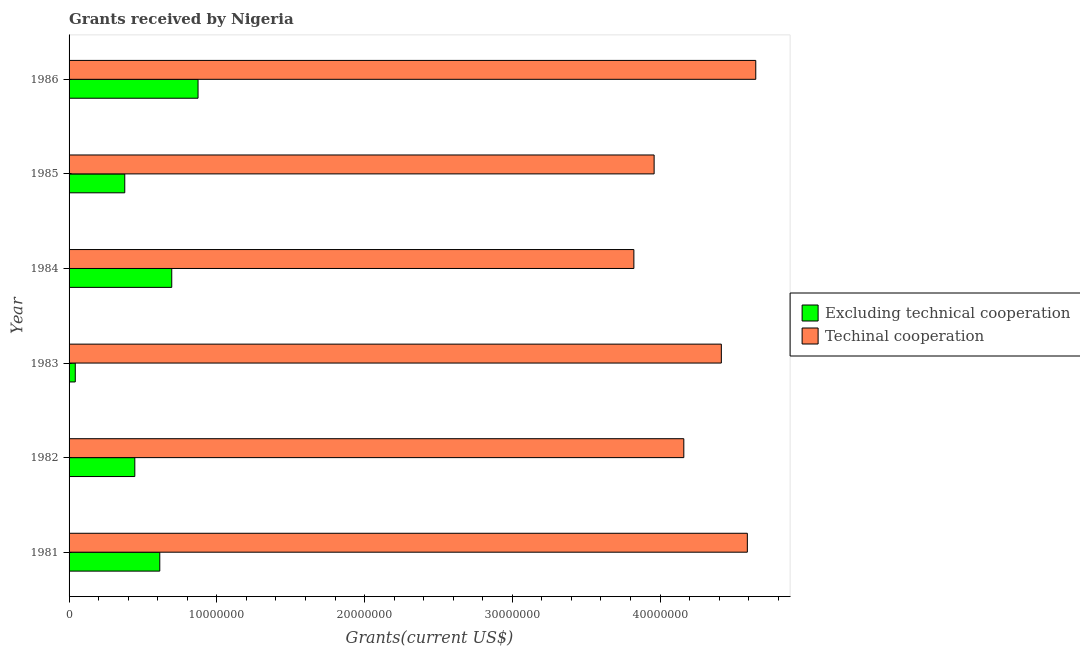How many different coloured bars are there?
Provide a short and direct response. 2. How many bars are there on the 1st tick from the top?
Offer a very short reply. 2. How many bars are there on the 1st tick from the bottom?
Keep it short and to the point. 2. What is the amount of grants received(excluding technical cooperation) in 1986?
Ensure brevity in your answer.  8.73e+06. Across all years, what is the maximum amount of grants received(including technical cooperation)?
Ensure brevity in your answer.  4.65e+07. Across all years, what is the minimum amount of grants received(including technical cooperation)?
Give a very brief answer. 3.82e+07. In which year was the amount of grants received(excluding technical cooperation) minimum?
Give a very brief answer. 1983. What is the total amount of grants received(excluding technical cooperation) in the graph?
Offer a very short reply. 3.05e+07. What is the difference between the amount of grants received(excluding technical cooperation) in 1984 and that in 1986?
Ensure brevity in your answer.  -1.78e+06. What is the difference between the amount of grants received(including technical cooperation) in 1986 and the amount of grants received(excluding technical cooperation) in 1984?
Your answer should be compact. 3.95e+07. What is the average amount of grants received(excluding technical cooperation) per year?
Provide a succinct answer. 5.08e+06. In the year 1981, what is the difference between the amount of grants received(excluding technical cooperation) and amount of grants received(including technical cooperation)?
Offer a very short reply. -3.98e+07. In how many years, is the amount of grants received(excluding technical cooperation) greater than 38000000 US$?
Make the answer very short. 0. What is the ratio of the amount of grants received(including technical cooperation) in 1981 to that in 1986?
Provide a succinct answer. 0.99. Is the amount of grants received(excluding technical cooperation) in 1983 less than that in 1986?
Offer a terse response. Yes. What is the difference between the highest and the second highest amount of grants received(excluding technical cooperation)?
Provide a short and direct response. 1.78e+06. What is the difference between the highest and the lowest amount of grants received(including technical cooperation)?
Offer a very short reply. 8.25e+06. Is the sum of the amount of grants received(excluding technical cooperation) in 1981 and 1985 greater than the maximum amount of grants received(including technical cooperation) across all years?
Offer a very short reply. No. What does the 1st bar from the top in 1983 represents?
Ensure brevity in your answer.  Techinal cooperation. What does the 1st bar from the bottom in 1982 represents?
Give a very brief answer. Excluding technical cooperation. Are the values on the major ticks of X-axis written in scientific E-notation?
Provide a succinct answer. No. Does the graph contain any zero values?
Your response must be concise. No. Does the graph contain grids?
Provide a short and direct response. No. How many legend labels are there?
Offer a terse response. 2. How are the legend labels stacked?
Make the answer very short. Vertical. What is the title of the graph?
Your answer should be very brief. Grants received by Nigeria. Does "Electricity" appear as one of the legend labels in the graph?
Provide a short and direct response. No. What is the label or title of the X-axis?
Make the answer very short. Grants(current US$). What is the label or title of the Y-axis?
Give a very brief answer. Year. What is the Grants(current US$) in Excluding technical cooperation in 1981?
Your answer should be very brief. 6.14e+06. What is the Grants(current US$) in Techinal cooperation in 1981?
Provide a short and direct response. 4.59e+07. What is the Grants(current US$) of Excluding technical cooperation in 1982?
Your answer should be compact. 4.45e+06. What is the Grants(current US$) in Techinal cooperation in 1982?
Keep it short and to the point. 4.16e+07. What is the Grants(current US$) in Excluding technical cooperation in 1983?
Provide a succinct answer. 4.20e+05. What is the Grants(current US$) of Techinal cooperation in 1983?
Your answer should be compact. 4.42e+07. What is the Grants(current US$) of Excluding technical cooperation in 1984?
Provide a succinct answer. 6.95e+06. What is the Grants(current US$) in Techinal cooperation in 1984?
Keep it short and to the point. 3.82e+07. What is the Grants(current US$) of Excluding technical cooperation in 1985?
Ensure brevity in your answer.  3.77e+06. What is the Grants(current US$) in Techinal cooperation in 1985?
Your response must be concise. 3.96e+07. What is the Grants(current US$) of Excluding technical cooperation in 1986?
Your response must be concise. 8.73e+06. What is the Grants(current US$) of Techinal cooperation in 1986?
Provide a short and direct response. 4.65e+07. Across all years, what is the maximum Grants(current US$) in Excluding technical cooperation?
Offer a terse response. 8.73e+06. Across all years, what is the maximum Grants(current US$) in Techinal cooperation?
Your answer should be very brief. 4.65e+07. Across all years, what is the minimum Grants(current US$) in Excluding technical cooperation?
Your answer should be compact. 4.20e+05. Across all years, what is the minimum Grants(current US$) in Techinal cooperation?
Your answer should be compact. 3.82e+07. What is the total Grants(current US$) in Excluding technical cooperation in the graph?
Give a very brief answer. 3.05e+07. What is the total Grants(current US$) of Techinal cooperation in the graph?
Offer a terse response. 2.56e+08. What is the difference between the Grants(current US$) in Excluding technical cooperation in 1981 and that in 1982?
Offer a terse response. 1.69e+06. What is the difference between the Grants(current US$) in Techinal cooperation in 1981 and that in 1982?
Provide a short and direct response. 4.30e+06. What is the difference between the Grants(current US$) of Excluding technical cooperation in 1981 and that in 1983?
Keep it short and to the point. 5.72e+06. What is the difference between the Grants(current US$) of Techinal cooperation in 1981 and that in 1983?
Keep it short and to the point. 1.76e+06. What is the difference between the Grants(current US$) in Excluding technical cooperation in 1981 and that in 1984?
Provide a succinct answer. -8.10e+05. What is the difference between the Grants(current US$) in Techinal cooperation in 1981 and that in 1984?
Your response must be concise. 7.68e+06. What is the difference between the Grants(current US$) in Excluding technical cooperation in 1981 and that in 1985?
Keep it short and to the point. 2.37e+06. What is the difference between the Grants(current US$) of Techinal cooperation in 1981 and that in 1985?
Offer a terse response. 6.31e+06. What is the difference between the Grants(current US$) in Excluding technical cooperation in 1981 and that in 1986?
Your response must be concise. -2.59e+06. What is the difference between the Grants(current US$) in Techinal cooperation in 1981 and that in 1986?
Your response must be concise. -5.70e+05. What is the difference between the Grants(current US$) in Excluding technical cooperation in 1982 and that in 1983?
Ensure brevity in your answer.  4.03e+06. What is the difference between the Grants(current US$) of Techinal cooperation in 1982 and that in 1983?
Offer a terse response. -2.54e+06. What is the difference between the Grants(current US$) in Excluding technical cooperation in 1982 and that in 1984?
Offer a very short reply. -2.50e+06. What is the difference between the Grants(current US$) of Techinal cooperation in 1982 and that in 1984?
Offer a very short reply. 3.38e+06. What is the difference between the Grants(current US$) of Excluding technical cooperation in 1982 and that in 1985?
Keep it short and to the point. 6.80e+05. What is the difference between the Grants(current US$) of Techinal cooperation in 1982 and that in 1985?
Your response must be concise. 2.01e+06. What is the difference between the Grants(current US$) in Excluding technical cooperation in 1982 and that in 1986?
Your response must be concise. -4.28e+06. What is the difference between the Grants(current US$) in Techinal cooperation in 1982 and that in 1986?
Give a very brief answer. -4.87e+06. What is the difference between the Grants(current US$) in Excluding technical cooperation in 1983 and that in 1984?
Your response must be concise. -6.53e+06. What is the difference between the Grants(current US$) of Techinal cooperation in 1983 and that in 1984?
Provide a short and direct response. 5.92e+06. What is the difference between the Grants(current US$) in Excluding technical cooperation in 1983 and that in 1985?
Offer a very short reply. -3.35e+06. What is the difference between the Grants(current US$) in Techinal cooperation in 1983 and that in 1985?
Keep it short and to the point. 4.55e+06. What is the difference between the Grants(current US$) of Excluding technical cooperation in 1983 and that in 1986?
Offer a terse response. -8.31e+06. What is the difference between the Grants(current US$) of Techinal cooperation in 1983 and that in 1986?
Make the answer very short. -2.33e+06. What is the difference between the Grants(current US$) of Excluding technical cooperation in 1984 and that in 1985?
Keep it short and to the point. 3.18e+06. What is the difference between the Grants(current US$) of Techinal cooperation in 1984 and that in 1985?
Offer a terse response. -1.37e+06. What is the difference between the Grants(current US$) of Excluding technical cooperation in 1984 and that in 1986?
Provide a short and direct response. -1.78e+06. What is the difference between the Grants(current US$) of Techinal cooperation in 1984 and that in 1986?
Your answer should be compact. -8.25e+06. What is the difference between the Grants(current US$) in Excluding technical cooperation in 1985 and that in 1986?
Your response must be concise. -4.96e+06. What is the difference between the Grants(current US$) of Techinal cooperation in 1985 and that in 1986?
Offer a terse response. -6.88e+06. What is the difference between the Grants(current US$) of Excluding technical cooperation in 1981 and the Grants(current US$) of Techinal cooperation in 1982?
Your response must be concise. -3.55e+07. What is the difference between the Grants(current US$) in Excluding technical cooperation in 1981 and the Grants(current US$) in Techinal cooperation in 1983?
Your answer should be compact. -3.80e+07. What is the difference between the Grants(current US$) of Excluding technical cooperation in 1981 and the Grants(current US$) of Techinal cooperation in 1984?
Provide a short and direct response. -3.21e+07. What is the difference between the Grants(current US$) in Excluding technical cooperation in 1981 and the Grants(current US$) in Techinal cooperation in 1985?
Ensure brevity in your answer.  -3.35e+07. What is the difference between the Grants(current US$) of Excluding technical cooperation in 1981 and the Grants(current US$) of Techinal cooperation in 1986?
Keep it short and to the point. -4.03e+07. What is the difference between the Grants(current US$) in Excluding technical cooperation in 1982 and the Grants(current US$) in Techinal cooperation in 1983?
Your response must be concise. -3.97e+07. What is the difference between the Grants(current US$) in Excluding technical cooperation in 1982 and the Grants(current US$) in Techinal cooperation in 1984?
Your answer should be compact. -3.38e+07. What is the difference between the Grants(current US$) of Excluding technical cooperation in 1982 and the Grants(current US$) of Techinal cooperation in 1985?
Ensure brevity in your answer.  -3.52e+07. What is the difference between the Grants(current US$) in Excluding technical cooperation in 1982 and the Grants(current US$) in Techinal cooperation in 1986?
Offer a terse response. -4.20e+07. What is the difference between the Grants(current US$) in Excluding technical cooperation in 1983 and the Grants(current US$) in Techinal cooperation in 1984?
Offer a terse response. -3.78e+07. What is the difference between the Grants(current US$) in Excluding technical cooperation in 1983 and the Grants(current US$) in Techinal cooperation in 1985?
Keep it short and to the point. -3.92e+07. What is the difference between the Grants(current US$) of Excluding technical cooperation in 1983 and the Grants(current US$) of Techinal cooperation in 1986?
Offer a terse response. -4.61e+07. What is the difference between the Grants(current US$) in Excluding technical cooperation in 1984 and the Grants(current US$) in Techinal cooperation in 1985?
Ensure brevity in your answer.  -3.26e+07. What is the difference between the Grants(current US$) of Excluding technical cooperation in 1984 and the Grants(current US$) of Techinal cooperation in 1986?
Ensure brevity in your answer.  -3.95e+07. What is the difference between the Grants(current US$) in Excluding technical cooperation in 1985 and the Grants(current US$) in Techinal cooperation in 1986?
Give a very brief answer. -4.27e+07. What is the average Grants(current US$) of Excluding technical cooperation per year?
Offer a terse response. 5.08e+06. What is the average Grants(current US$) of Techinal cooperation per year?
Provide a short and direct response. 4.27e+07. In the year 1981, what is the difference between the Grants(current US$) in Excluding technical cooperation and Grants(current US$) in Techinal cooperation?
Ensure brevity in your answer.  -3.98e+07. In the year 1982, what is the difference between the Grants(current US$) in Excluding technical cooperation and Grants(current US$) in Techinal cooperation?
Your answer should be compact. -3.72e+07. In the year 1983, what is the difference between the Grants(current US$) in Excluding technical cooperation and Grants(current US$) in Techinal cooperation?
Give a very brief answer. -4.37e+07. In the year 1984, what is the difference between the Grants(current US$) in Excluding technical cooperation and Grants(current US$) in Techinal cooperation?
Your answer should be compact. -3.13e+07. In the year 1985, what is the difference between the Grants(current US$) of Excluding technical cooperation and Grants(current US$) of Techinal cooperation?
Your answer should be very brief. -3.58e+07. In the year 1986, what is the difference between the Grants(current US$) of Excluding technical cooperation and Grants(current US$) of Techinal cooperation?
Make the answer very short. -3.78e+07. What is the ratio of the Grants(current US$) in Excluding technical cooperation in 1981 to that in 1982?
Provide a short and direct response. 1.38. What is the ratio of the Grants(current US$) of Techinal cooperation in 1981 to that in 1982?
Your response must be concise. 1.1. What is the ratio of the Grants(current US$) of Excluding technical cooperation in 1981 to that in 1983?
Offer a very short reply. 14.62. What is the ratio of the Grants(current US$) of Techinal cooperation in 1981 to that in 1983?
Offer a terse response. 1.04. What is the ratio of the Grants(current US$) in Excluding technical cooperation in 1981 to that in 1984?
Keep it short and to the point. 0.88. What is the ratio of the Grants(current US$) of Techinal cooperation in 1981 to that in 1984?
Keep it short and to the point. 1.2. What is the ratio of the Grants(current US$) in Excluding technical cooperation in 1981 to that in 1985?
Offer a very short reply. 1.63. What is the ratio of the Grants(current US$) of Techinal cooperation in 1981 to that in 1985?
Your answer should be compact. 1.16. What is the ratio of the Grants(current US$) of Excluding technical cooperation in 1981 to that in 1986?
Keep it short and to the point. 0.7. What is the ratio of the Grants(current US$) in Techinal cooperation in 1981 to that in 1986?
Offer a terse response. 0.99. What is the ratio of the Grants(current US$) of Excluding technical cooperation in 1982 to that in 1983?
Your response must be concise. 10.6. What is the ratio of the Grants(current US$) of Techinal cooperation in 1982 to that in 1983?
Provide a succinct answer. 0.94. What is the ratio of the Grants(current US$) of Excluding technical cooperation in 1982 to that in 1984?
Make the answer very short. 0.64. What is the ratio of the Grants(current US$) in Techinal cooperation in 1982 to that in 1984?
Keep it short and to the point. 1.09. What is the ratio of the Grants(current US$) in Excluding technical cooperation in 1982 to that in 1985?
Offer a very short reply. 1.18. What is the ratio of the Grants(current US$) of Techinal cooperation in 1982 to that in 1985?
Make the answer very short. 1.05. What is the ratio of the Grants(current US$) of Excluding technical cooperation in 1982 to that in 1986?
Your answer should be compact. 0.51. What is the ratio of the Grants(current US$) in Techinal cooperation in 1982 to that in 1986?
Provide a short and direct response. 0.9. What is the ratio of the Grants(current US$) of Excluding technical cooperation in 1983 to that in 1984?
Give a very brief answer. 0.06. What is the ratio of the Grants(current US$) in Techinal cooperation in 1983 to that in 1984?
Make the answer very short. 1.15. What is the ratio of the Grants(current US$) of Excluding technical cooperation in 1983 to that in 1985?
Make the answer very short. 0.11. What is the ratio of the Grants(current US$) in Techinal cooperation in 1983 to that in 1985?
Ensure brevity in your answer.  1.11. What is the ratio of the Grants(current US$) of Excluding technical cooperation in 1983 to that in 1986?
Provide a short and direct response. 0.05. What is the ratio of the Grants(current US$) in Techinal cooperation in 1983 to that in 1986?
Provide a short and direct response. 0.95. What is the ratio of the Grants(current US$) in Excluding technical cooperation in 1984 to that in 1985?
Make the answer very short. 1.84. What is the ratio of the Grants(current US$) in Techinal cooperation in 1984 to that in 1985?
Your response must be concise. 0.97. What is the ratio of the Grants(current US$) in Excluding technical cooperation in 1984 to that in 1986?
Provide a succinct answer. 0.8. What is the ratio of the Grants(current US$) of Techinal cooperation in 1984 to that in 1986?
Give a very brief answer. 0.82. What is the ratio of the Grants(current US$) in Excluding technical cooperation in 1985 to that in 1986?
Provide a short and direct response. 0.43. What is the ratio of the Grants(current US$) in Techinal cooperation in 1985 to that in 1986?
Your response must be concise. 0.85. What is the difference between the highest and the second highest Grants(current US$) of Excluding technical cooperation?
Give a very brief answer. 1.78e+06. What is the difference between the highest and the second highest Grants(current US$) in Techinal cooperation?
Offer a very short reply. 5.70e+05. What is the difference between the highest and the lowest Grants(current US$) in Excluding technical cooperation?
Offer a very short reply. 8.31e+06. What is the difference between the highest and the lowest Grants(current US$) of Techinal cooperation?
Your answer should be compact. 8.25e+06. 